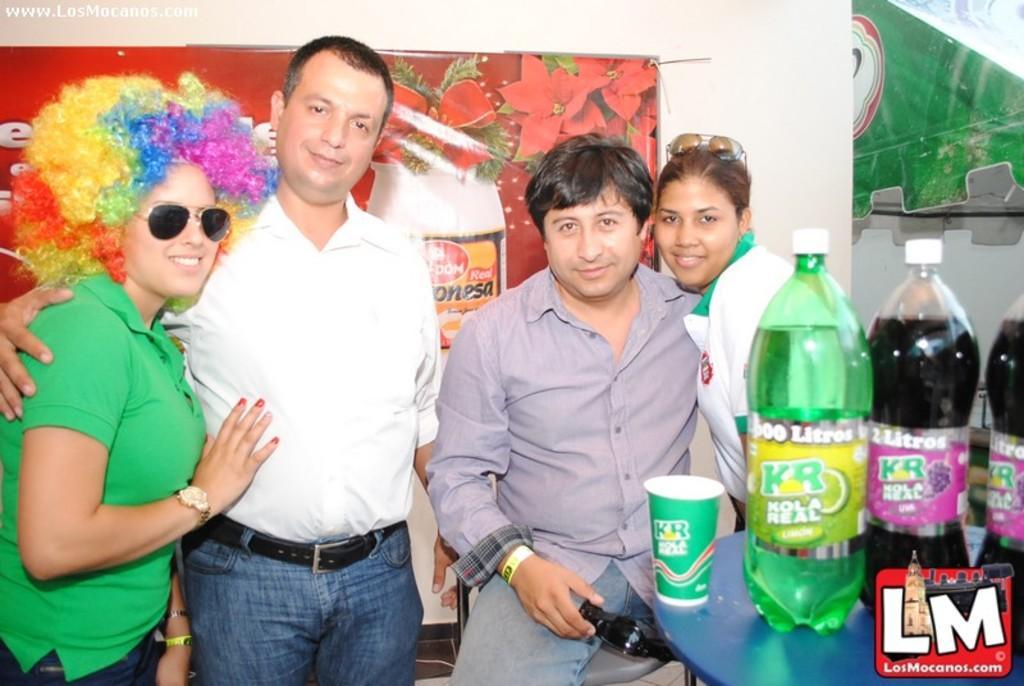Could you give a brief overview of what you see in this image? In this image its a woman standing and smiling with black color goggles , and a man standing and smiling , a woman and man standing and smiling and in the table there is a glass, bottles and at the background there is a banner attached to the wall. 